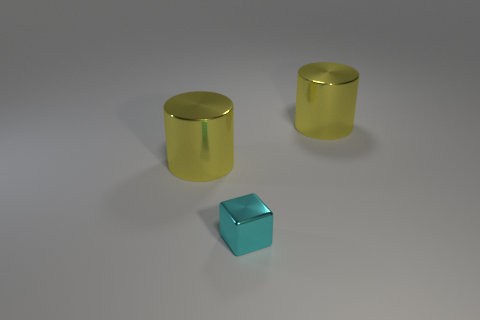Can you describe the colors of the objects in the image? Certainly! In the image, we have two large cylinders and a small block. The cylinders have a golden yellow color with a reflective surface, while the block boasts a metallic, sky blue tone, also with a reflective finish. 